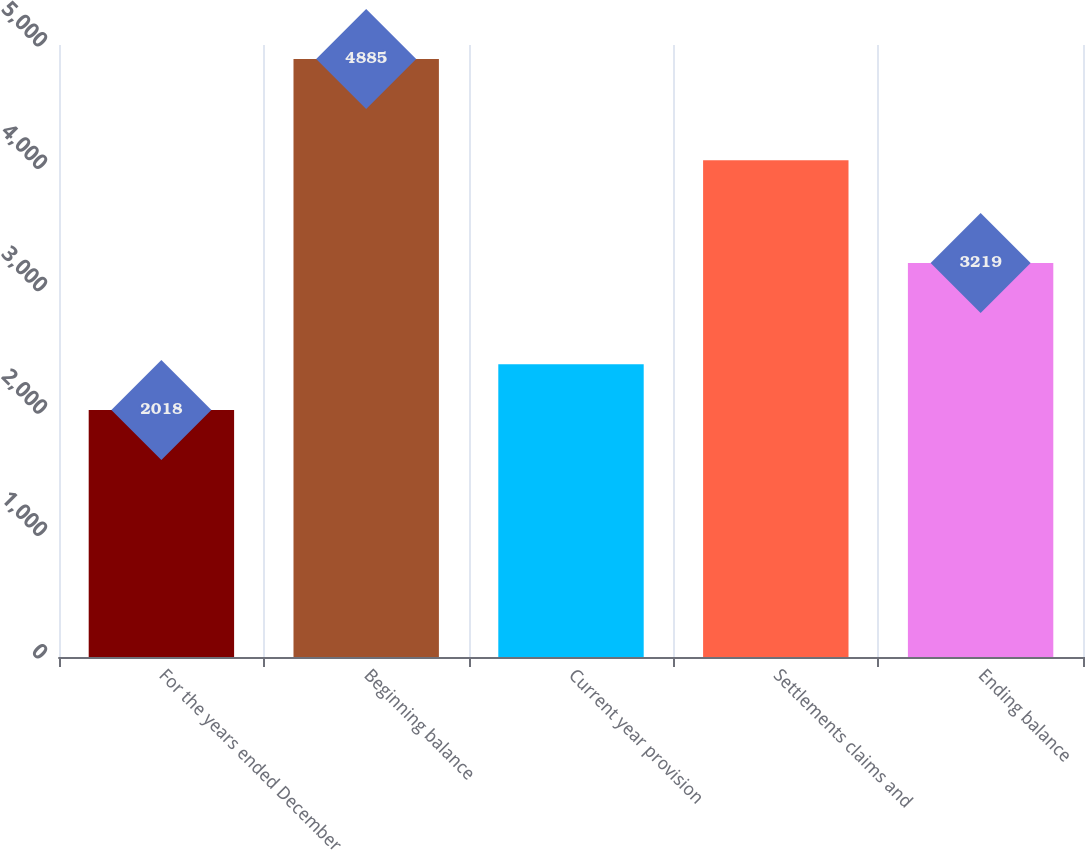Convert chart to OTSL. <chart><loc_0><loc_0><loc_500><loc_500><bar_chart><fcel>For the years ended December<fcel>Beginning balance<fcel>Current year provision<fcel>Settlements claims and<fcel>Ending balance<nl><fcel>2018<fcel>4885<fcel>2392<fcel>4058<fcel>3219<nl></chart> 